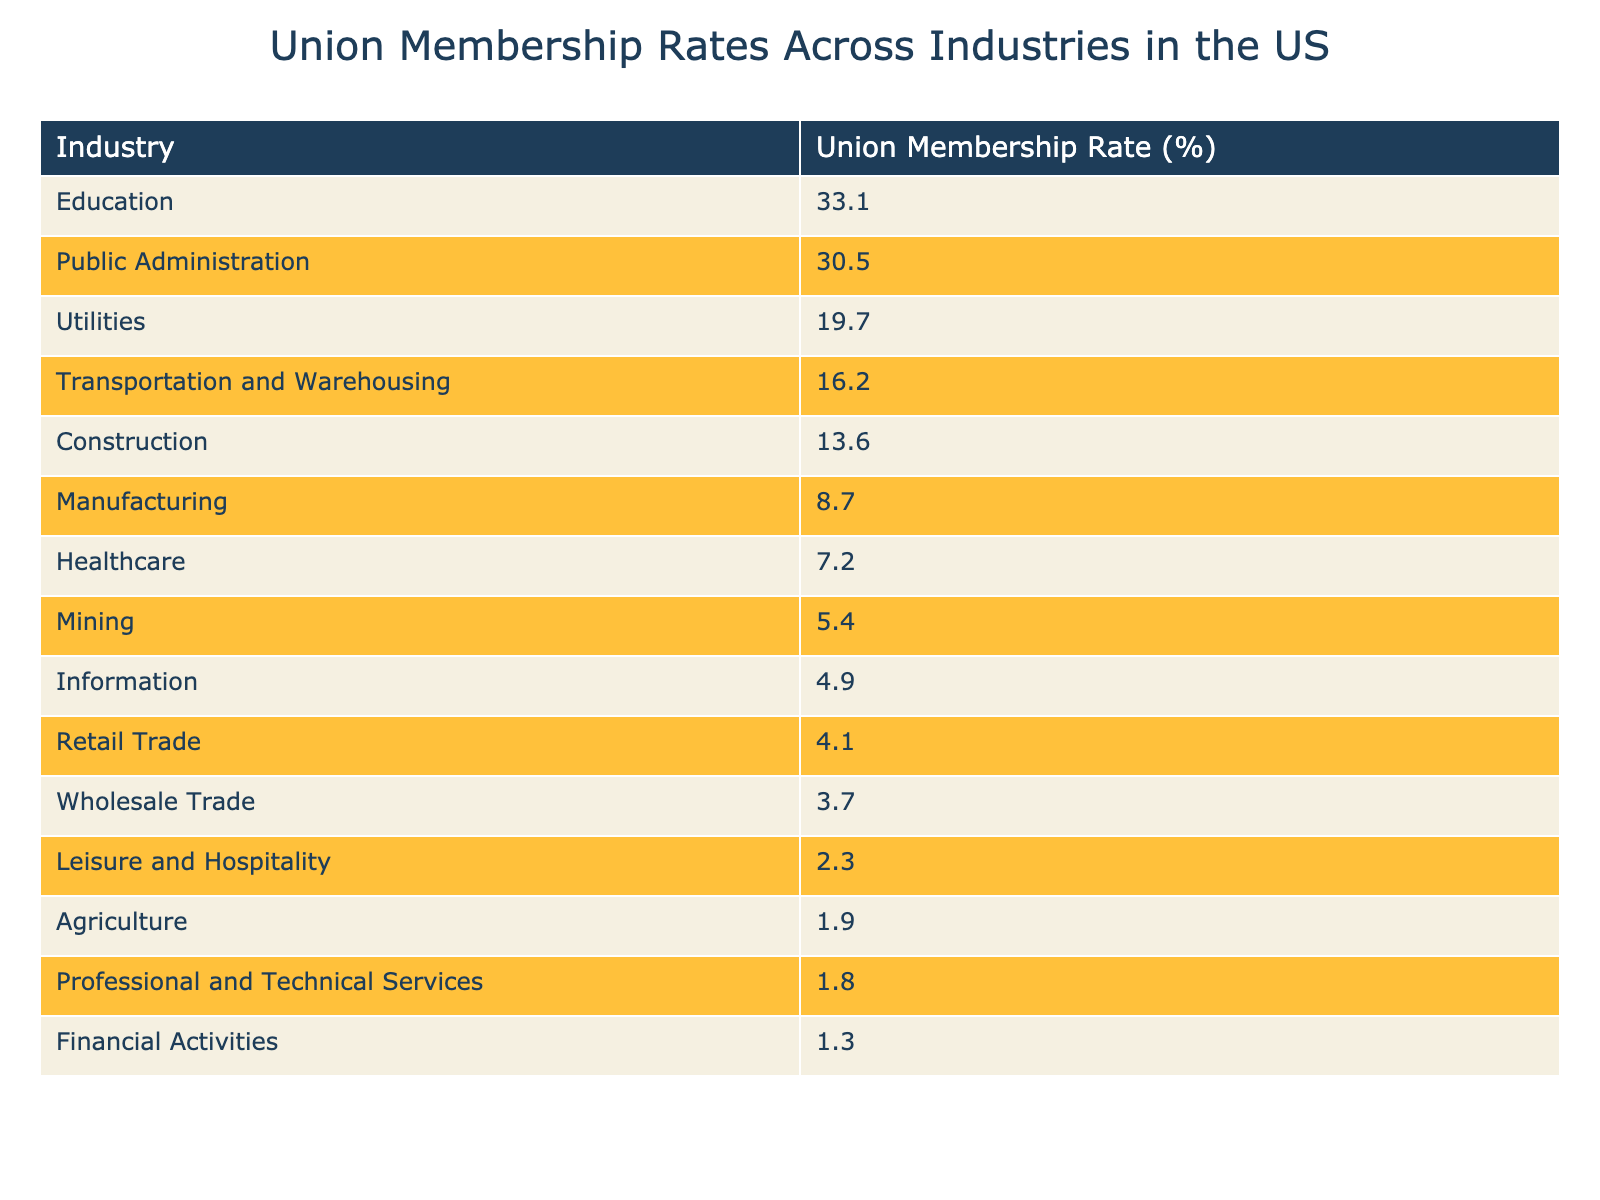What is the highest union membership rate among the industries listed? The highest value in the "Union Membership Rate (%)" column is 33.1, which corresponds to the Education industry.
Answer: 33.1 Which industry has the lowest union membership rate? The lowest value in the "Union Membership Rate (%)" column is 1.3, which corresponds to the Financial Activities industry.
Answer: 1.3 What is the union membership rate for the Construction industry? Referring to the table, the Union Membership Rate for the Construction industry is 13.6%.
Answer: 13.6 Is the union membership rate in Healthcare higher than in Retail Trade? The Healthcare industry has a rate of 7.2% and the Retail Trade has 4.1%. Since 7.2 is greater than 4.1, the answer is yes.
Answer: Yes What is the difference in union membership rates between Public Administration and Transportation and Warehousing? The rate for Public Administration is 30.5% and for Transportation and Warehousing is 16.2%. The difference is 30.5 - 16.2 = 14.3%.
Answer: 14.3 Which industries have a union membership rate greater than 10%? By examining the table, the industries with rates above 10% are Construction (13.6%), Transportation and Warehousing (16.2%), Education (33.1%), and Public Administration (30.5%).
Answer: Construction, Transportation and Warehousing, Education, Public Administration What is the average union membership rate for the industries listed? To calculate the average, add all the membership rates together: (8.7 + 13.6 + 16.2 + 33.1 + 7.2 + 4.1 + 4.9 + 1.8 + 2.3 + 30.5 + 19.7 + 5.4 + 1.3 + 3.7 + 1.9) = 166.8, then divide by the number of industries (15): 166.8 / 15 = 11.12.
Answer: 11.12 Which industry has a union membership rate above 15% but below 20%? From the table, Utilities has a membership rate of 19.7%, which is above 15% and below 20%.
Answer: Utilities Can you name any industry where the union membership rate is less than 5%? The Retail Trade industry has a membership rate of 4.1%, which is less than 5%.
Answer: Yes, Retail Trade Which two industries combined have a union membership rate close to 20%? The combination of Transportation and Warehousing (16.2%) and Utilities (19.7%) gives a total of 35.9%, which exceeds 20%. Looking for individual combinations, the combination of Construction (13.6%) plus Retail Trade (4.1%) sums to 17.7%.
Answer: Construction and Retail Trade Which industry has a higher membership rate: Agriculture or Mining? Agriculture has a rate of 1.9% and Mining has 5.4%, thus Mining has a higher rate.
Answer: Mining 